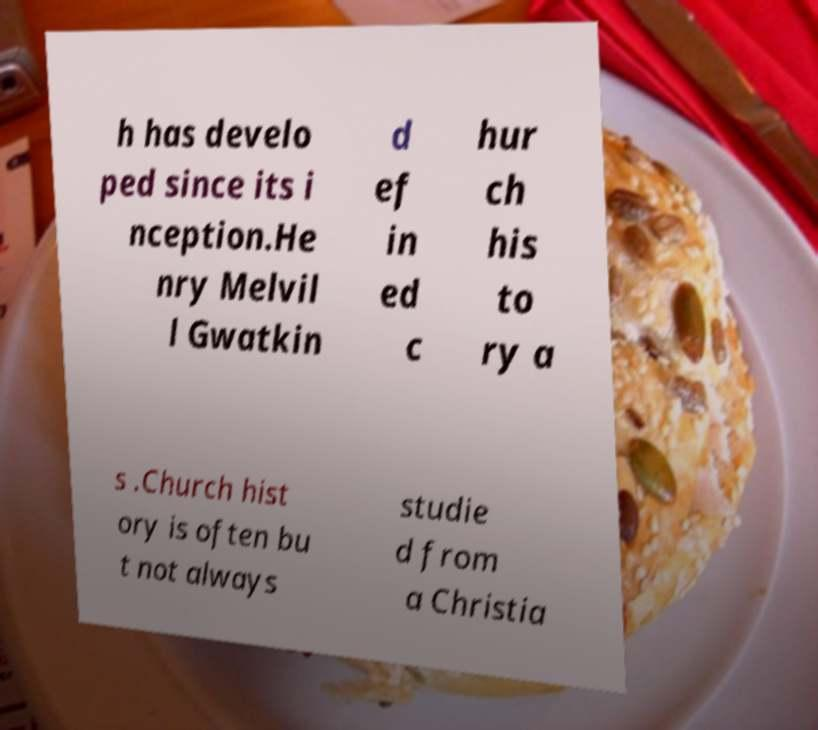Please read and relay the text visible in this image. What does it say? h has develo ped since its i nception.He nry Melvil l Gwatkin d ef in ed c hur ch his to ry a s .Church hist ory is often bu t not always studie d from a Christia 